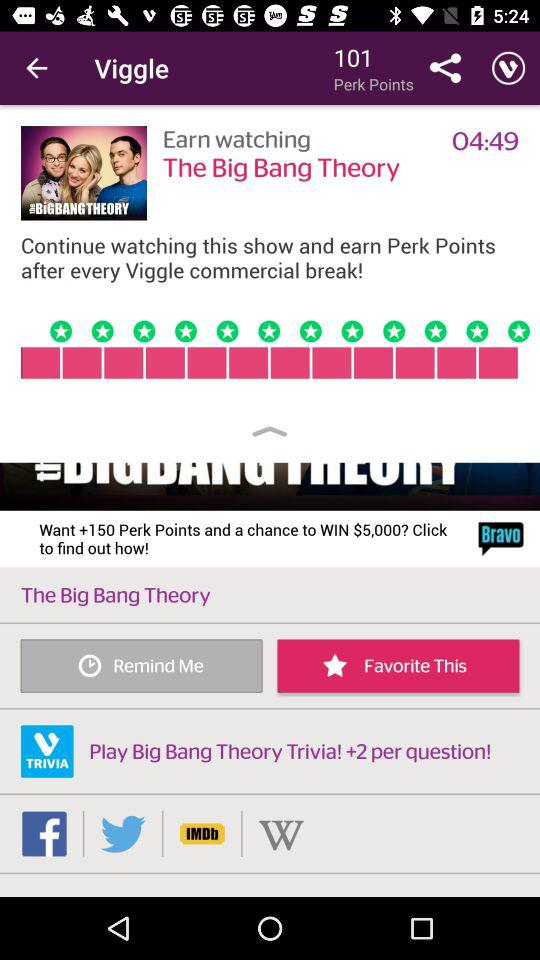What is the duration of the big bang theory? The duration is 04:49. 